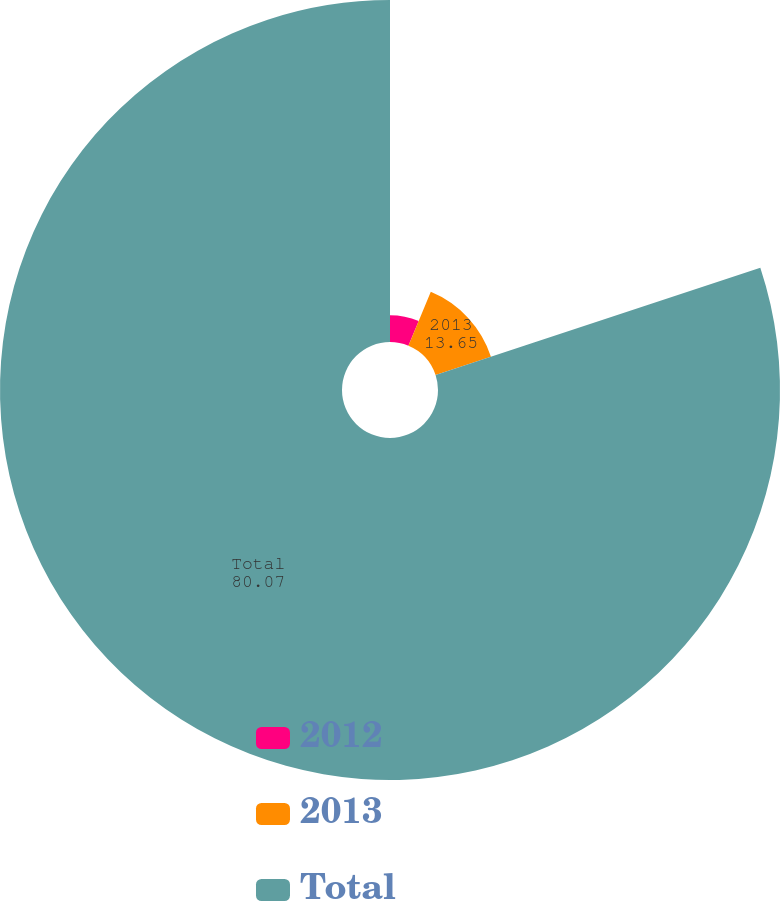Convert chart. <chart><loc_0><loc_0><loc_500><loc_500><pie_chart><fcel>2012<fcel>2013<fcel>Total<nl><fcel>6.27%<fcel>13.65%<fcel>80.07%<nl></chart> 